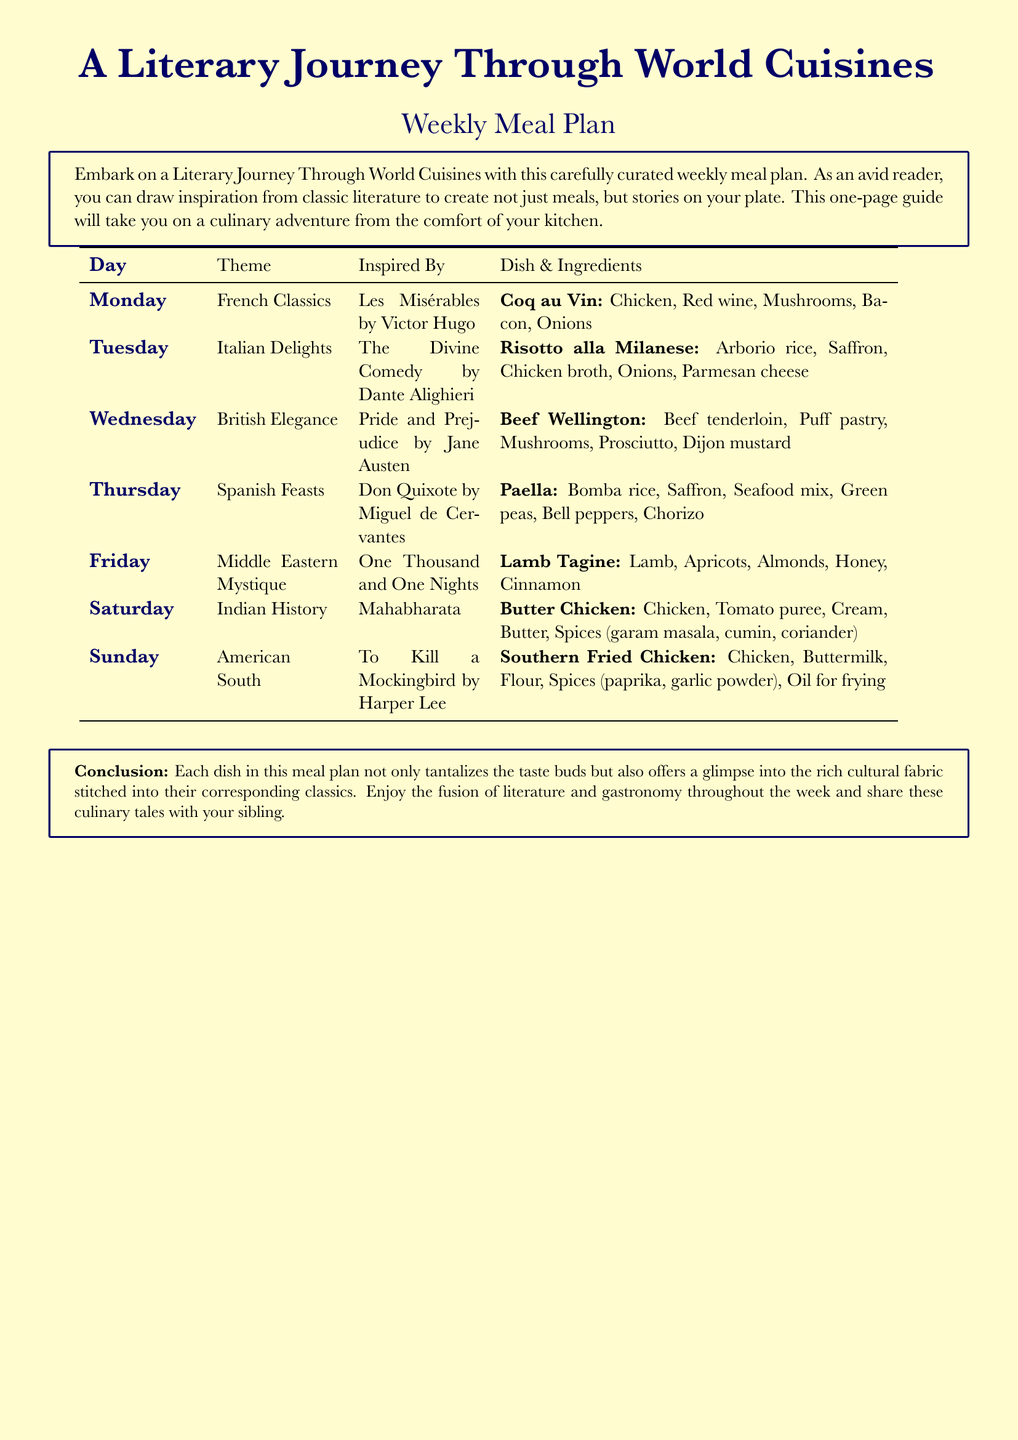What is the theme for Wednesday? The theme for Wednesday is stated in the meal plan as "British Elegance."
Answer: British Elegance What dish is inspired by Les Misérables? The dish associated with Les Misérables is mentioned as "Coq au Vin."
Answer: Coq au Vin What ingredients are used in Risotto alla Milanese? The meal plan lists the ingredients for Risotto alla Milanese as "Arborio rice, Saffron, Chicken broth, Onions, Parmesan cheese."
Answer: Arborio rice, Saffron, Chicken broth, Onions, Parmesan cheese Which classic literature inspired the dish "Southern Fried Chicken"? The classic literature mentioned for Southern Fried Chicken is "To Kill a Mockingbird by Harper Lee."
Answer: To Kill a Mockingbird by Harper Lee How many dishes are listed in the meal plan? The total number of dishes corresponds to the number of days in the meal plan, which accounts for seven days.
Answer: Seven What cuisine is served on Sunday? The document specifies the cuisine for Sunday as "American South."
Answer: American South Which dish contains saffron? The meal plan indicates that "Paella" contains saffron as one of its ingredients.
Answer: Paella What is the main ingredient in Beef Wellington? The primary ingredient listed for Beef Wellington is "Beef tenderloin."
Answer: Beef tenderloin Which day is dedicated to Indian cuisine? The meal plan designates Saturday for Indian cuisine.
Answer: Saturday 